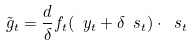<formula> <loc_0><loc_0><loc_500><loc_500>\tilde { g } _ { t } = \frac { d } { \delta } f _ { t } ( \ y _ { t } + \delta \ s _ { t } ) \cdot \ s _ { t }</formula> 